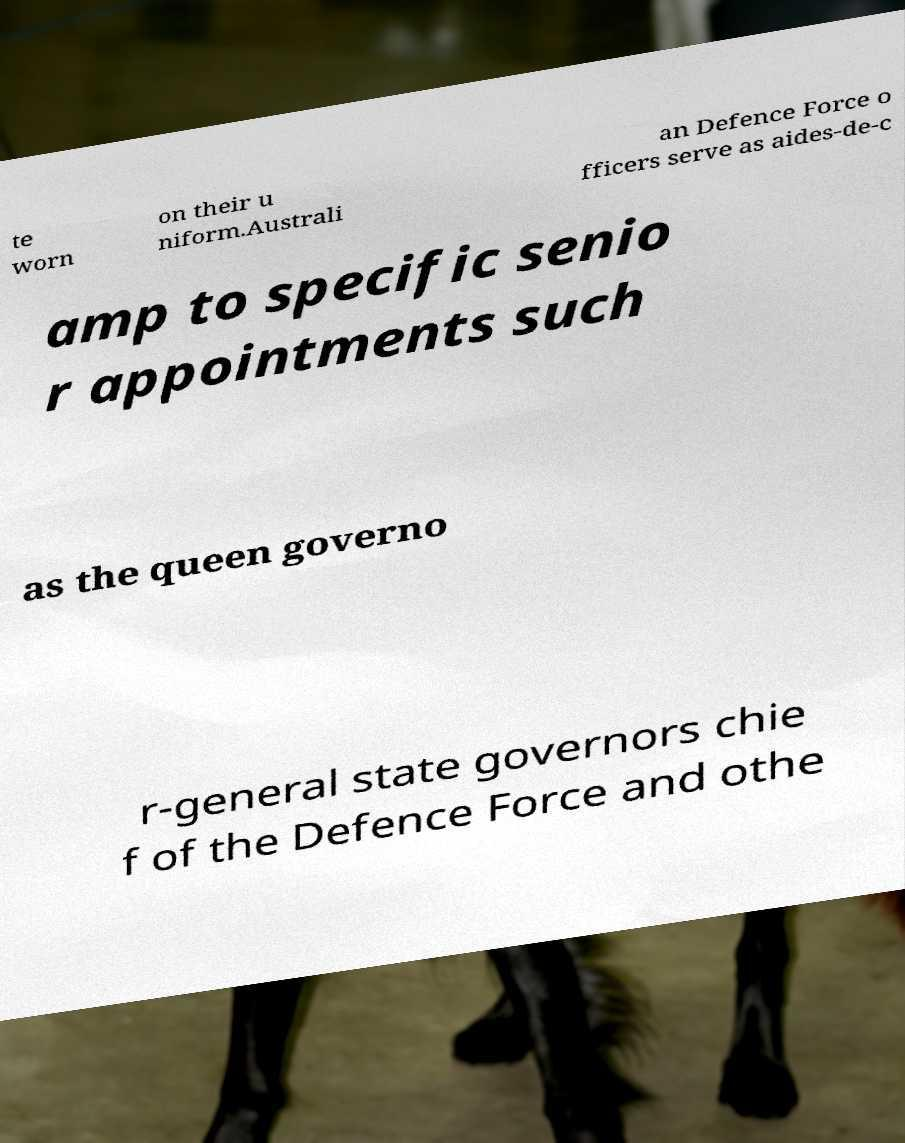For documentation purposes, I need the text within this image transcribed. Could you provide that? te worn on their u niform.Australi an Defence Force o fficers serve as aides-de-c amp to specific senio r appointments such as the queen governo r-general state governors chie f of the Defence Force and othe 